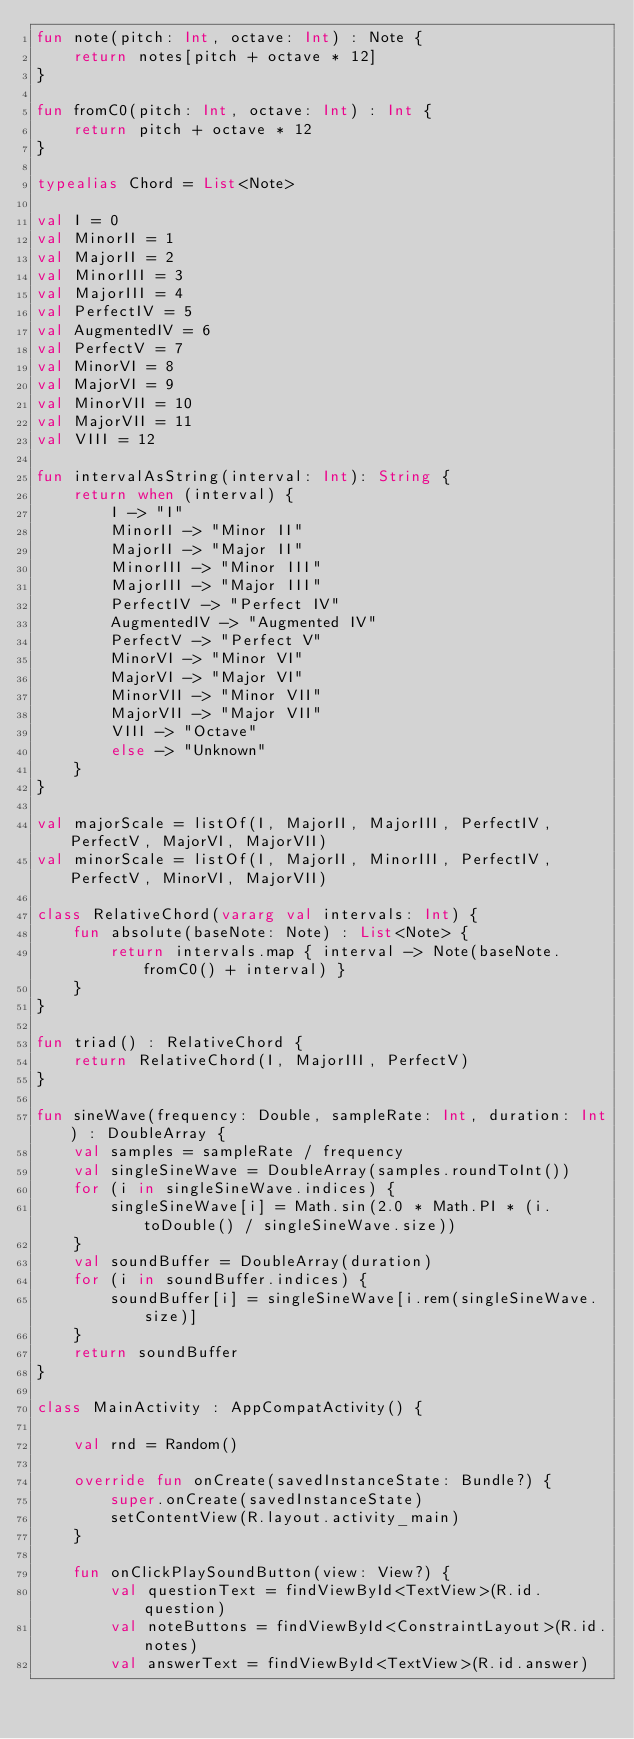<code> <loc_0><loc_0><loc_500><loc_500><_Kotlin_>fun note(pitch: Int, octave: Int) : Note {
    return notes[pitch + octave * 12]
}

fun fromC0(pitch: Int, octave: Int) : Int {
    return pitch + octave * 12
}

typealias Chord = List<Note>

val I = 0
val MinorII = 1
val MajorII = 2
val MinorIII = 3
val MajorIII = 4
val PerfectIV = 5
val AugmentedIV = 6
val PerfectV = 7
val MinorVI = 8
val MajorVI = 9
val MinorVII = 10
val MajorVII = 11
val VIII = 12

fun intervalAsString(interval: Int): String {
    return when (interval) {
        I -> "I"
        MinorII -> "Minor II"
        MajorII -> "Major II"
        MinorIII -> "Minor III"
        MajorIII -> "Major III"
        PerfectIV -> "Perfect IV"
        AugmentedIV -> "Augmented IV"
        PerfectV -> "Perfect V"
        MinorVI -> "Minor VI"
        MajorVI -> "Major VI"
        MinorVII -> "Minor VII"
        MajorVII -> "Major VII"
        VIII -> "Octave"
        else -> "Unknown"
    }
}

val majorScale = listOf(I, MajorII, MajorIII, PerfectIV, PerfectV, MajorVI, MajorVII)
val minorScale = listOf(I, MajorII, MinorIII, PerfectIV, PerfectV, MinorVI, MajorVII)

class RelativeChord(vararg val intervals: Int) {
    fun absolute(baseNote: Note) : List<Note> {
        return intervals.map { interval -> Note(baseNote.fromC0() + interval) }
    }
}

fun triad() : RelativeChord {
    return RelativeChord(I, MajorIII, PerfectV)
}

fun sineWave(frequency: Double, sampleRate: Int, duration: Int) : DoubleArray {
    val samples = sampleRate / frequency
    val singleSineWave = DoubleArray(samples.roundToInt())
    for (i in singleSineWave.indices) {
        singleSineWave[i] = Math.sin(2.0 * Math.PI * (i.toDouble() / singleSineWave.size))
    }
    val soundBuffer = DoubleArray(duration)
    for (i in soundBuffer.indices) {
        soundBuffer[i] = singleSineWave[i.rem(singleSineWave.size)]
    }
    return soundBuffer
}

class MainActivity : AppCompatActivity() {

    val rnd = Random()

    override fun onCreate(savedInstanceState: Bundle?) {
        super.onCreate(savedInstanceState)
        setContentView(R.layout.activity_main)
    }

    fun onClickPlaySoundButton(view: View?) {
        val questionText = findViewById<TextView>(R.id.question)
        val noteButtons = findViewById<ConstraintLayout>(R.id.notes)
        val answerText = findViewById<TextView>(R.id.answer)</code> 